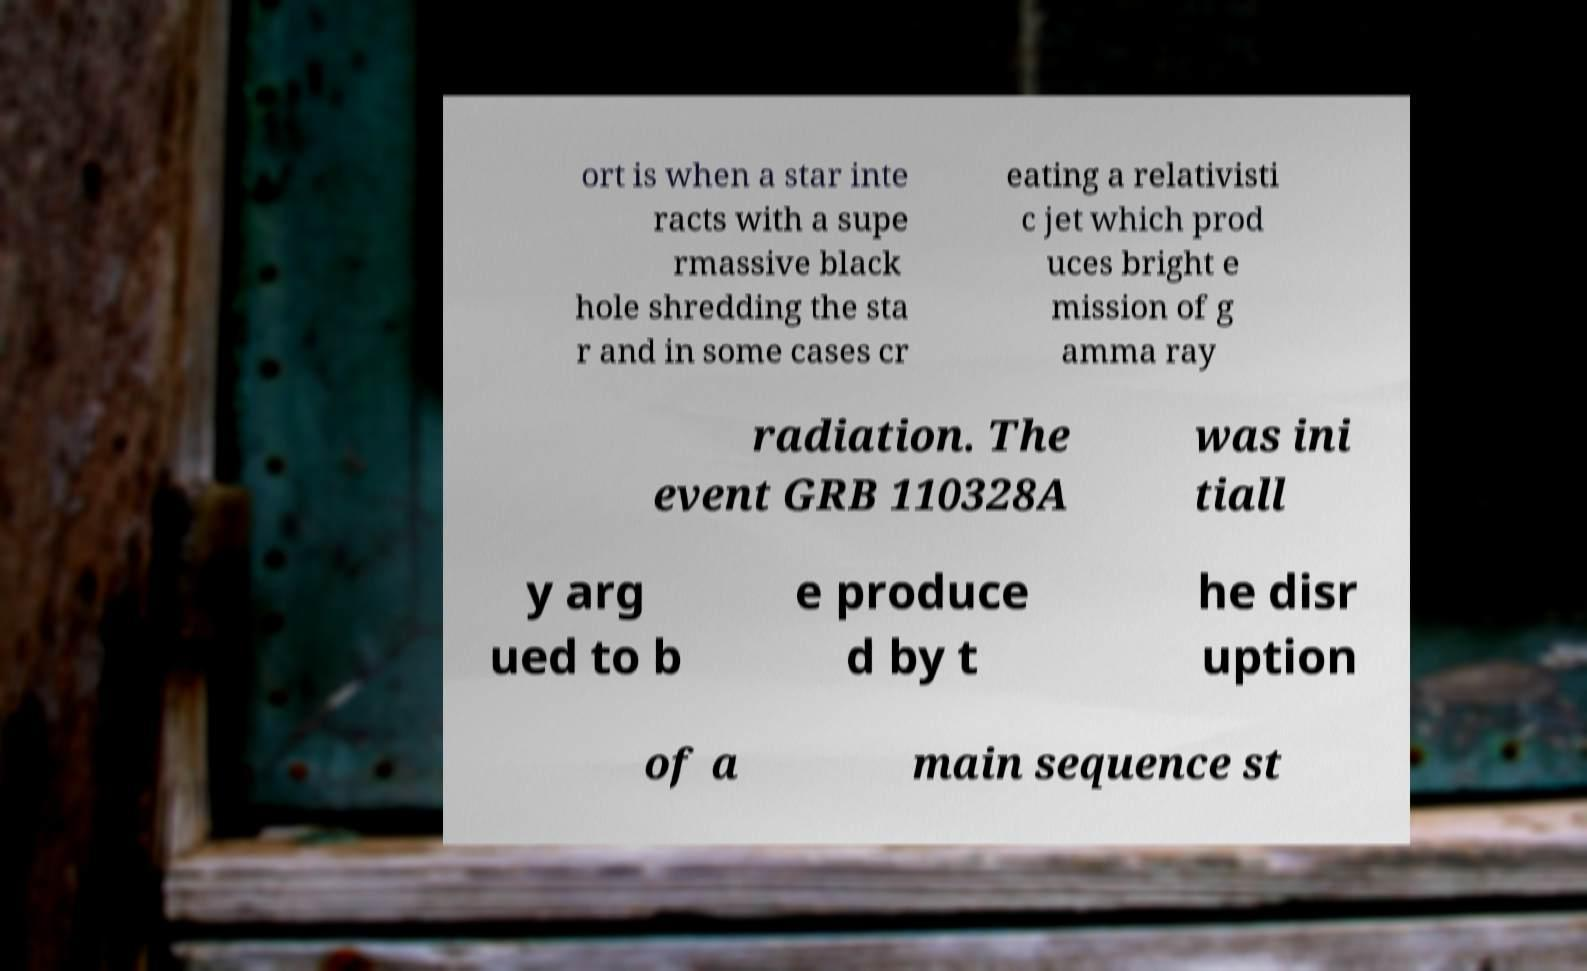Please read and relay the text visible in this image. What does it say? ort is when a star inte racts with a supe rmassive black hole shredding the sta r and in some cases cr eating a relativisti c jet which prod uces bright e mission of g amma ray radiation. The event GRB 110328A was ini tiall y arg ued to b e produce d by t he disr uption of a main sequence st 